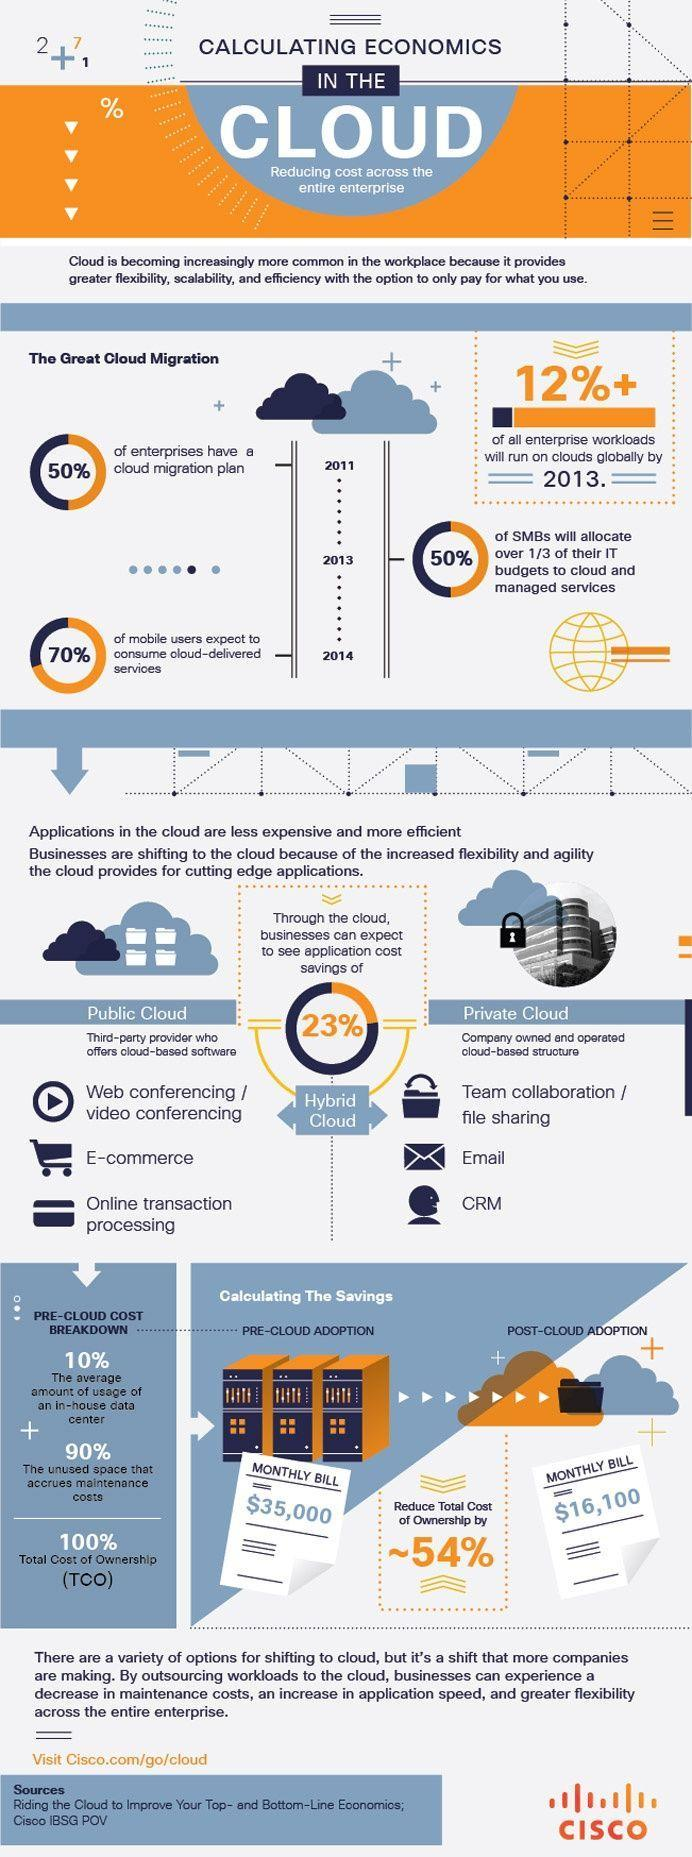How much will be monthly bill post cloud adoption?
Answer the question with a short phrase. $16,100 How much can be saved using cloud? 23% What percent of enterprises do not have a cloud migration plan? 50% 